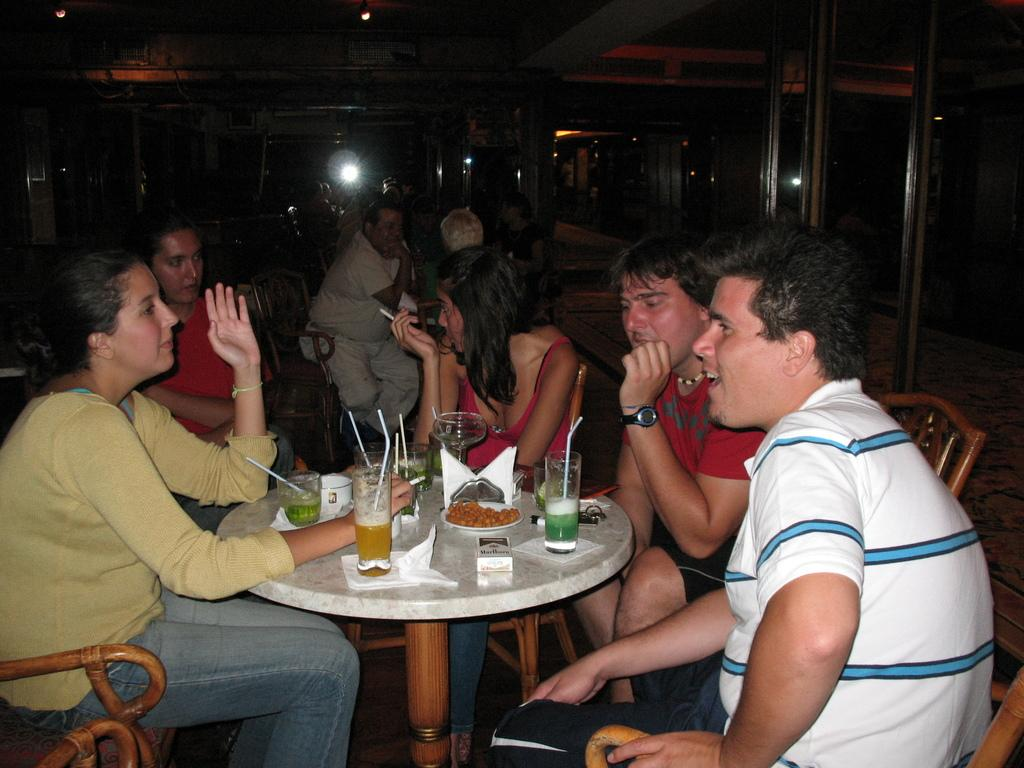How many people are in the image? There is a group of people in the image, but the exact number is not specified. What are the people doing in the image? The people are sitting on chairs in the image. What is on the table in front of the people? There are juice glasses present on the table. What can be seen in the background of the image? There are lights visible in the background of the image. What type of copper wheel is visible in the image? There is no copper wheel present in the image. 